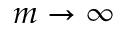<formula> <loc_0><loc_0><loc_500><loc_500>m \to \infty</formula> 